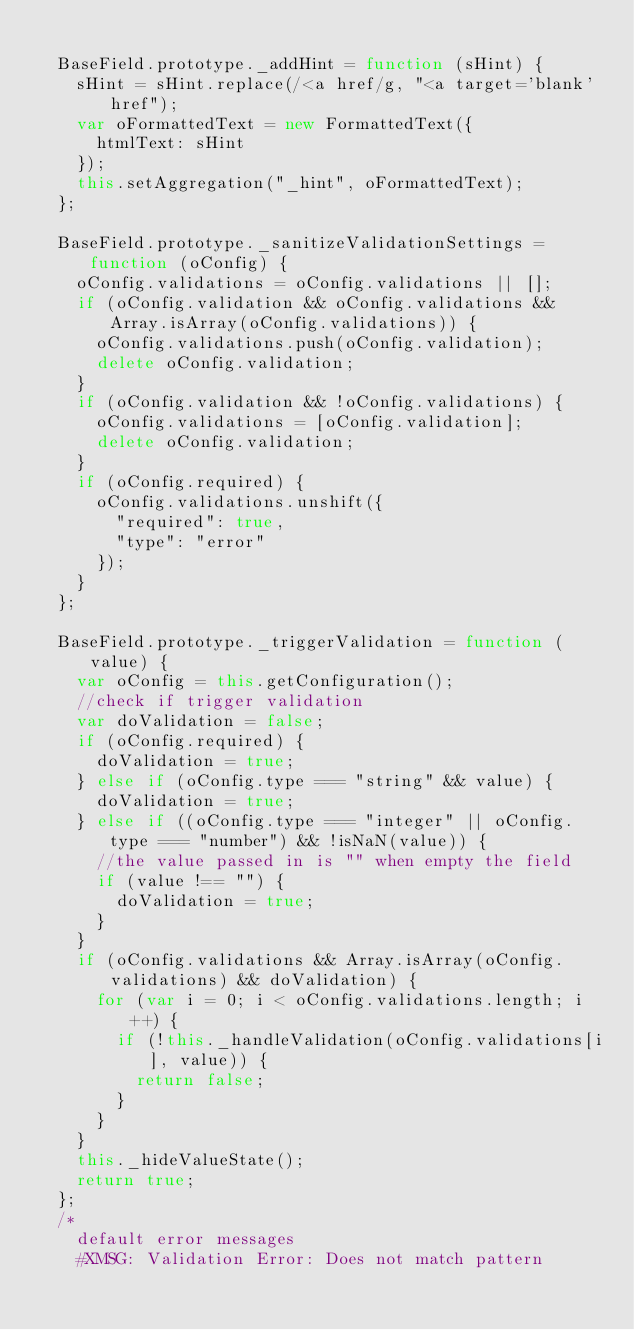<code> <loc_0><loc_0><loc_500><loc_500><_JavaScript_>
	BaseField.prototype._addHint = function (sHint) {
		sHint = sHint.replace(/<a href/g, "<a target='blank' href");
		var oFormattedText = new FormattedText({
			htmlText: sHint
		});
		this.setAggregation("_hint", oFormattedText);
	};

	BaseField.prototype._sanitizeValidationSettings = function (oConfig) {
		oConfig.validations = oConfig.validations || [];
		if (oConfig.validation && oConfig.validations && Array.isArray(oConfig.validations)) {
			oConfig.validations.push(oConfig.validation);
			delete oConfig.validation;
		}
		if (oConfig.validation && !oConfig.validations) {
			oConfig.validations = [oConfig.validation];
			delete oConfig.validation;
		}
		if (oConfig.required) {
			oConfig.validations.unshift({
				"required": true,
				"type": "error"
			});
		}
	};

	BaseField.prototype._triggerValidation = function (value) {
		var oConfig = this.getConfiguration();
		//check if trigger validation
		var doValidation = false;
		if (oConfig.required) {
			doValidation = true;
		} else if (oConfig.type === "string" && value) {
			doValidation = true;
		} else if ((oConfig.type === "integer" || oConfig.type === "number") && !isNaN(value)) {
			//the value passed in is "" when empty the field
			if (value !== "") {
				doValidation = true;
			}
		}
		if (oConfig.validations && Array.isArray(oConfig.validations) && doValidation) {
			for (var i = 0; i < oConfig.validations.length; i++) {
				if (!this._handleValidation(oConfig.validations[i], value)) {
					return false;
				}
			}
		}
		this._hideValueState();
		return true;
	};
	/*
		default error messages
		#XMSG: Validation Error: Does not match pattern</code> 